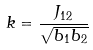Convert formula to latex. <formula><loc_0><loc_0><loc_500><loc_500>k = \frac { J _ { 1 2 } } { \sqrt { b _ { 1 } b _ { 2 } } }</formula> 